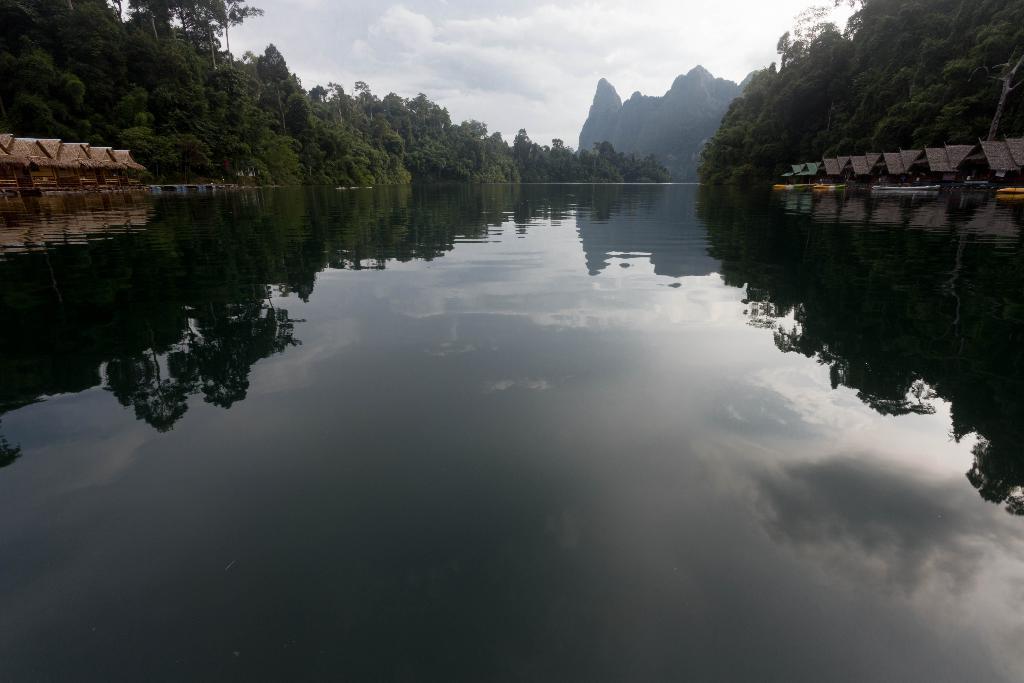How would you summarize this image in a sentence or two? In this image, I can see water. On the left and right side of the image, I can see the houses and trees. In the background, there is a hill and I can see the sky. 